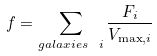Convert formula to latex. <formula><loc_0><loc_0><loc_500><loc_500>f = \sum _ { { g a l a x i e s \ } i } \frac { F _ { i } } { V _ { \max , i } }</formula> 